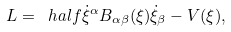<formula> <loc_0><loc_0><loc_500><loc_500>L = \ h a l f \dot { \xi } ^ { \alpha } B _ { \alpha \beta } ( \xi ) \dot { \xi } _ { \beta } - V ( \xi ) ,</formula> 